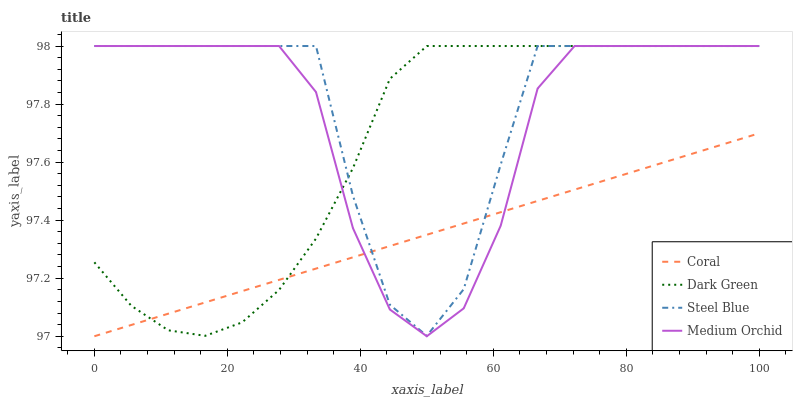Does Coral have the minimum area under the curve?
Answer yes or no. Yes. Does Steel Blue have the maximum area under the curve?
Answer yes or no. Yes. Does Medium Orchid have the minimum area under the curve?
Answer yes or no. No. Does Medium Orchid have the maximum area under the curve?
Answer yes or no. No. Is Coral the smoothest?
Answer yes or no. Yes. Is Steel Blue the roughest?
Answer yes or no. Yes. Is Medium Orchid the smoothest?
Answer yes or no. No. Is Medium Orchid the roughest?
Answer yes or no. No. Does Coral have the lowest value?
Answer yes or no. Yes. Does Medium Orchid have the lowest value?
Answer yes or no. No. Does Dark Green have the highest value?
Answer yes or no. Yes. Does Steel Blue intersect Dark Green?
Answer yes or no. Yes. Is Steel Blue less than Dark Green?
Answer yes or no. No. Is Steel Blue greater than Dark Green?
Answer yes or no. No. 